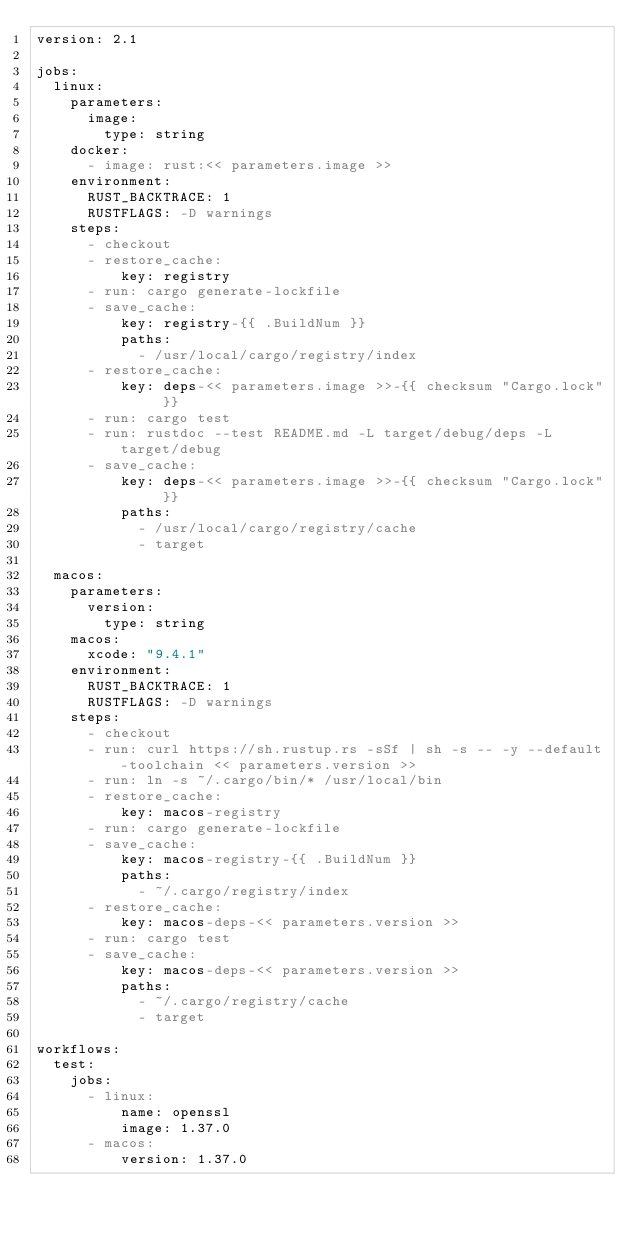Convert code to text. <code><loc_0><loc_0><loc_500><loc_500><_YAML_>version: 2.1

jobs:
  linux:
    parameters:
      image:
        type: string
    docker:
      - image: rust:<< parameters.image >>
    environment:
      RUST_BACKTRACE: 1
      RUSTFLAGS: -D warnings
    steps:
      - checkout
      - restore_cache:
          key: registry
      - run: cargo generate-lockfile
      - save_cache:
          key: registry-{{ .BuildNum }}
          paths:
            - /usr/local/cargo/registry/index
      - restore_cache:
          key: deps-<< parameters.image >>-{{ checksum "Cargo.lock" }}
      - run: cargo test
      - run: rustdoc --test README.md -L target/debug/deps -L target/debug
      - save_cache:
          key: deps-<< parameters.image >>-{{ checksum "Cargo.lock" }}
          paths:
            - /usr/local/cargo/registry/cache
            - target

  macos:
    parameters:
      version:
        type: string
    macos:
      xcode: "9.4.1"
    environment:
      RUST_BACKTRACE: 1
      RUSTFLAGS: -D warnings
    steps:
      - checkout
      - run: curl https://sh.rustup.rs -sSf | sh -s -- -y --default-toolchain << parameters.version >>
      - run: ln -s ~/.cargo/bin/* /usr/local/bin
      - restore_cache:
          key: macos-registry
      - run: cargo generate-lockfile
      - save_cache:
          key: macos-registry-{{ .BuildNum }}
          paths:
            - ~/.cargo/registry/index
      - restore_cache:
          key: macos-deps-<< parameters.version >>
      - run: cargo test
      - save_cache:
          key: macos-deps-<< parameters.version >>
          paths:
            - ~/.cargo/registry/cache
            - target

workflows:
  test:
    jobs:
      - linux:
          name: openssl
          image: 1.37.0
      - macos:
          version: 1.37.0
</code> 